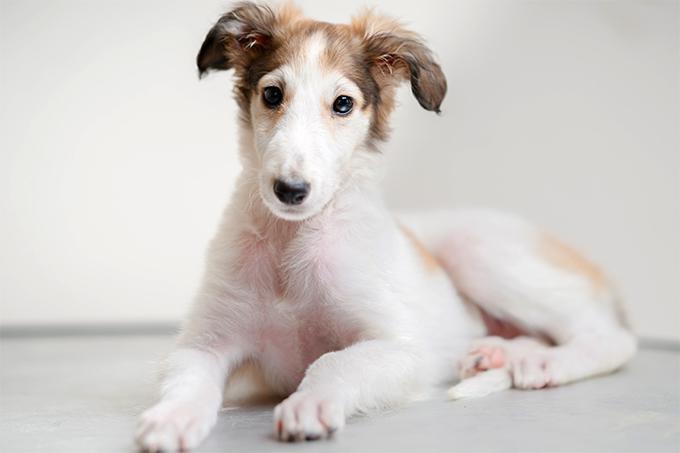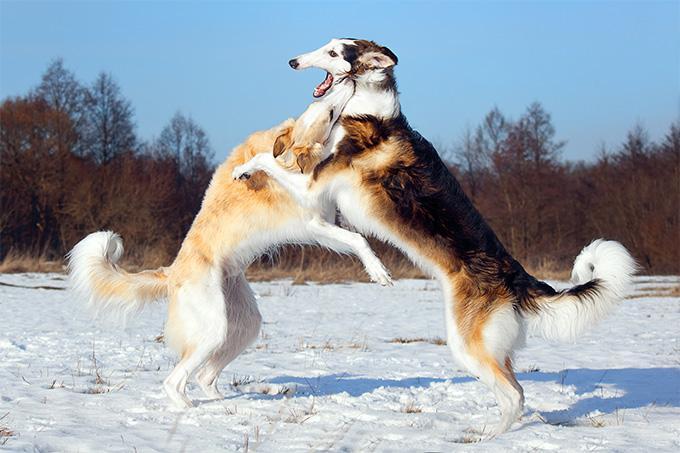The first image is the image on the left, the second image is the image on the right. Evaluate the accuracy of this statement regarding the images: "There are at most two dogs.". Is it true? Answer yes or no. No. 